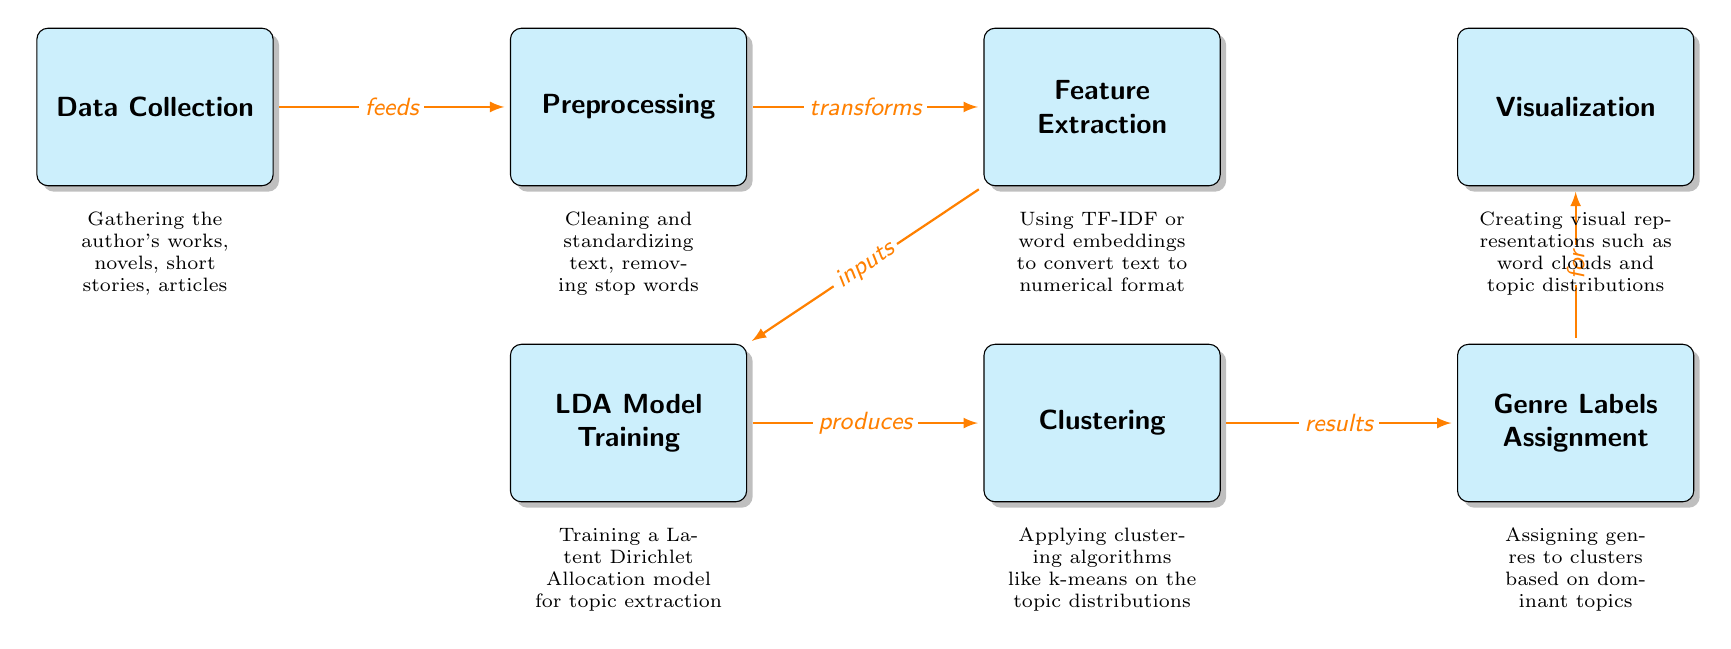What is the first step in the diagram? The first step is represented by the node labeled "Data Collection," which indicates that the process begins with gathering the author's works.
Answer: Data Collection How many primary nodes are present in the diagram? There are seven primary nodes in the diagram, each representing a different stage in the genre classification process.
Answer: Seven What is the relationship between 'Preprocessing' and 'Feature Extraction'? The relationship is defined by an arrow labeled "transforms," meaning that Preprocessing transforms the data before it proceeds to Feature Extraction.
Answer: Transforms Which model is used for topic extraction according to the diagram? The diagram specifies that the "LDA Model" is used for training in the context of topic extraction, indicating a focus on Latent Dirichlet Allocation.
Answer: LDA Model What results from the 'Clustering' node? The Clustering node produces results that assist in the subsequent assignment of genre labels based on the clustered topic distributions.
Answer: Results How does 'Feature Extraction' relate to 'LDA Model Training'? Feature Extraction is the step that provides input to the LDA Model Training, implying that the numerical feature representation is necessary for the model training to occur.
Answer: Inputs Explain the flow from 'Genre Labels Assignment' to 'Visualization'. The flow from Genre Labels Assignment to Visualization is indicated by an arrow labeled "for," meaning that the assigned genre labels are then used to create visual representations of the data such as word clouds and topic distributions.
Answer: For What method is applied during 'Clustering'? The method highlighted during Clustering is the application of algorithms like k-means, which are employed to group similar topic distributions together based on the data.
Answer: K-means What does the 'Preprocessing' step involve according to the diagram? The Preprocessing step involves cleaning and standardizing the text, which includes actions such as removing stop words to prepare the data for further analysis.
Answer: Cleaning and standardizing text 